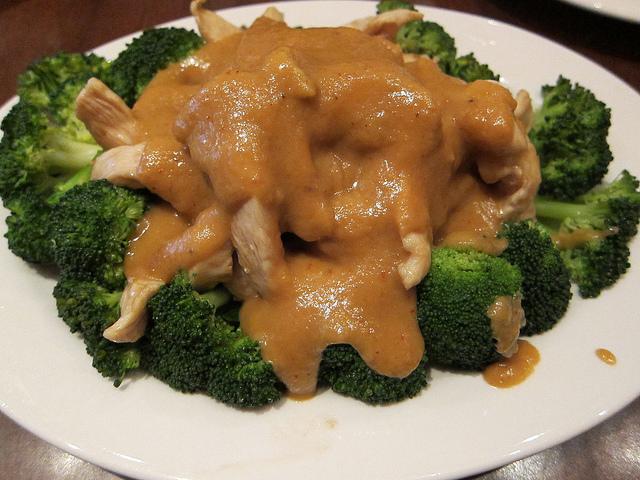What kind of vegetable is on the plate?
Write a very short answer. Broccoli. Is the plates color red?
Give a very brief answer. No. Do you think this is for dinner?
Write a very short answer. Yes. 